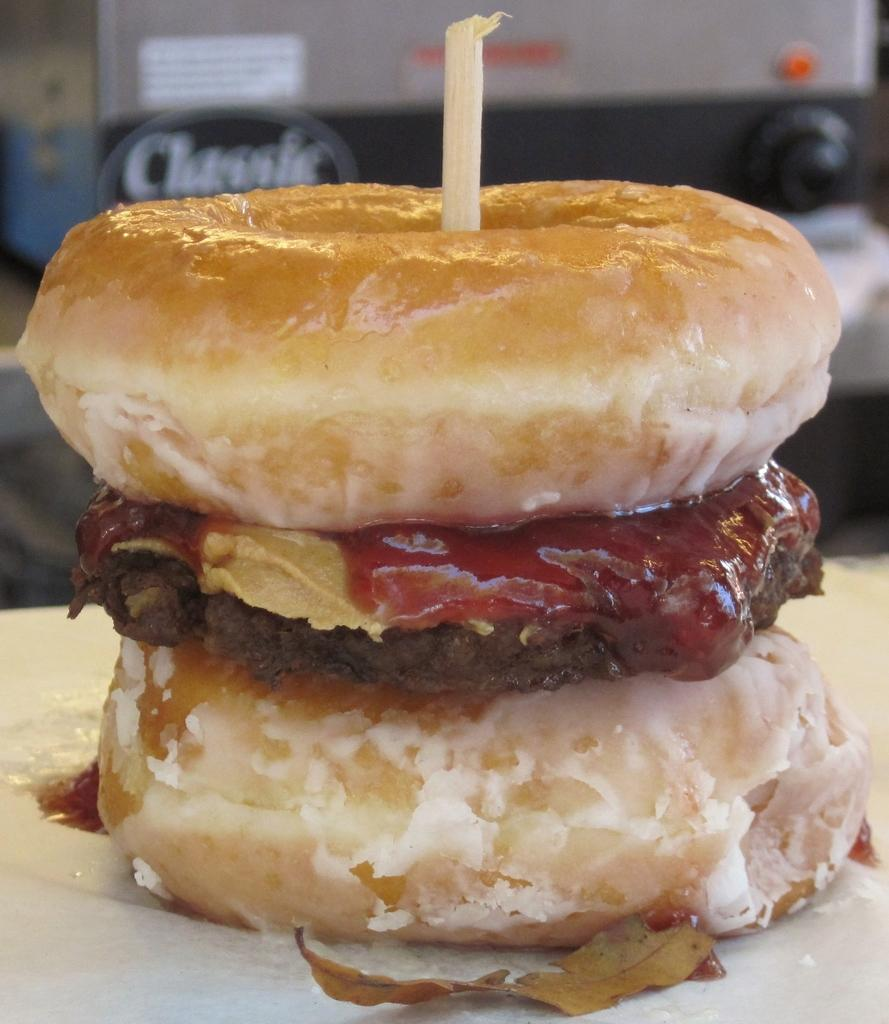What type of food can be seen in the image? The food in the image has brown and red colors. Can you describe the surface on which the food is placed? The food is on some surface, but the specific material or texture is not mentioned in the facts. What colors are predominant in the food? The food has brown and red colors. How many chickens are visible in the image? There are no chickens present in the image. What type of apples can be seen in the image? There are no apples present in the image. 